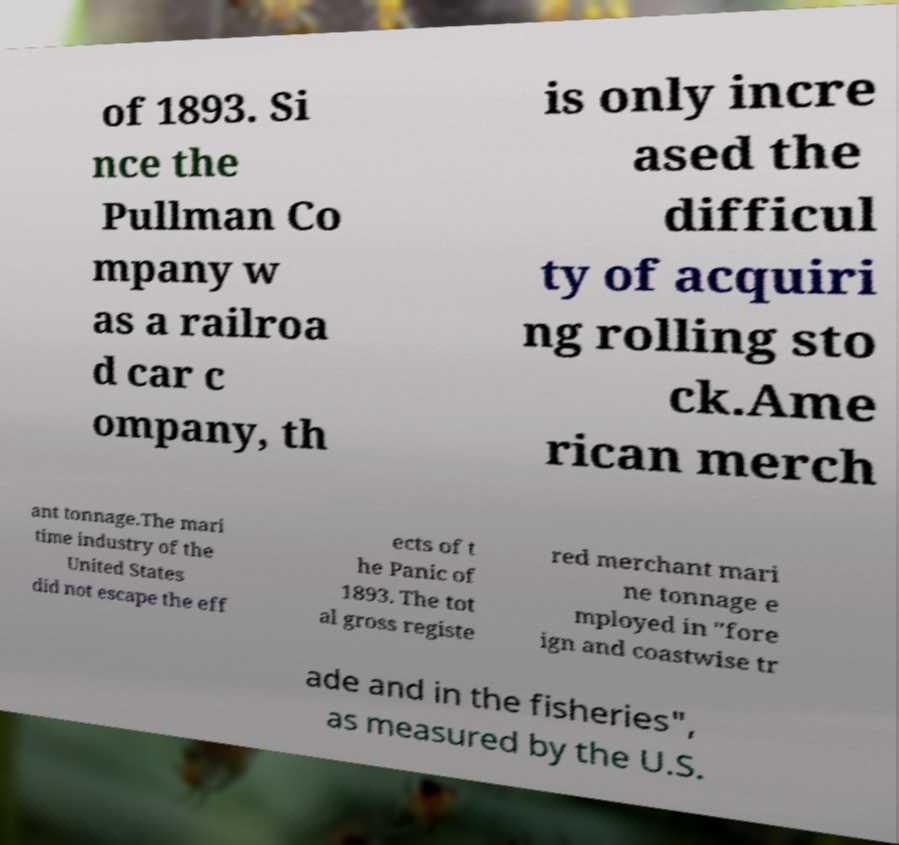There's text embedded in this image that I need extracted. Can you transcribe it verbatim? of 1893. Si nce the Pullman Co mpany w as a railroa d car c ompany, th is only incre ased the difficul ty of acquiri ng rolling sto ck.Ame rican merch ant tonnage.The mari time industry of the United States did not escape the eff ects of t he Panic of 1893. The tot al gross registe red merchant mari ne tonnage e mployed in "fore ign and coastwise tr ade and in the fisheries", as measured by the U.S. 